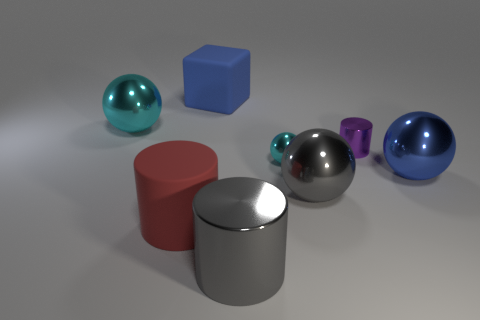Add 2 brown matte cubes. How many objects exist? 10 Subtract all cylinders. How many objects are left? 5 Add 1 large cyan metal spheres. How many large cyan metal spheres exist? 2 Subtract 1 gray cylinders. How many objects are left? 7 Subtract all large red metallic cubes. Subtract all purple things. How many objects are left? 7 Add 4 matte blocks. How many matte blocks are left? 5 